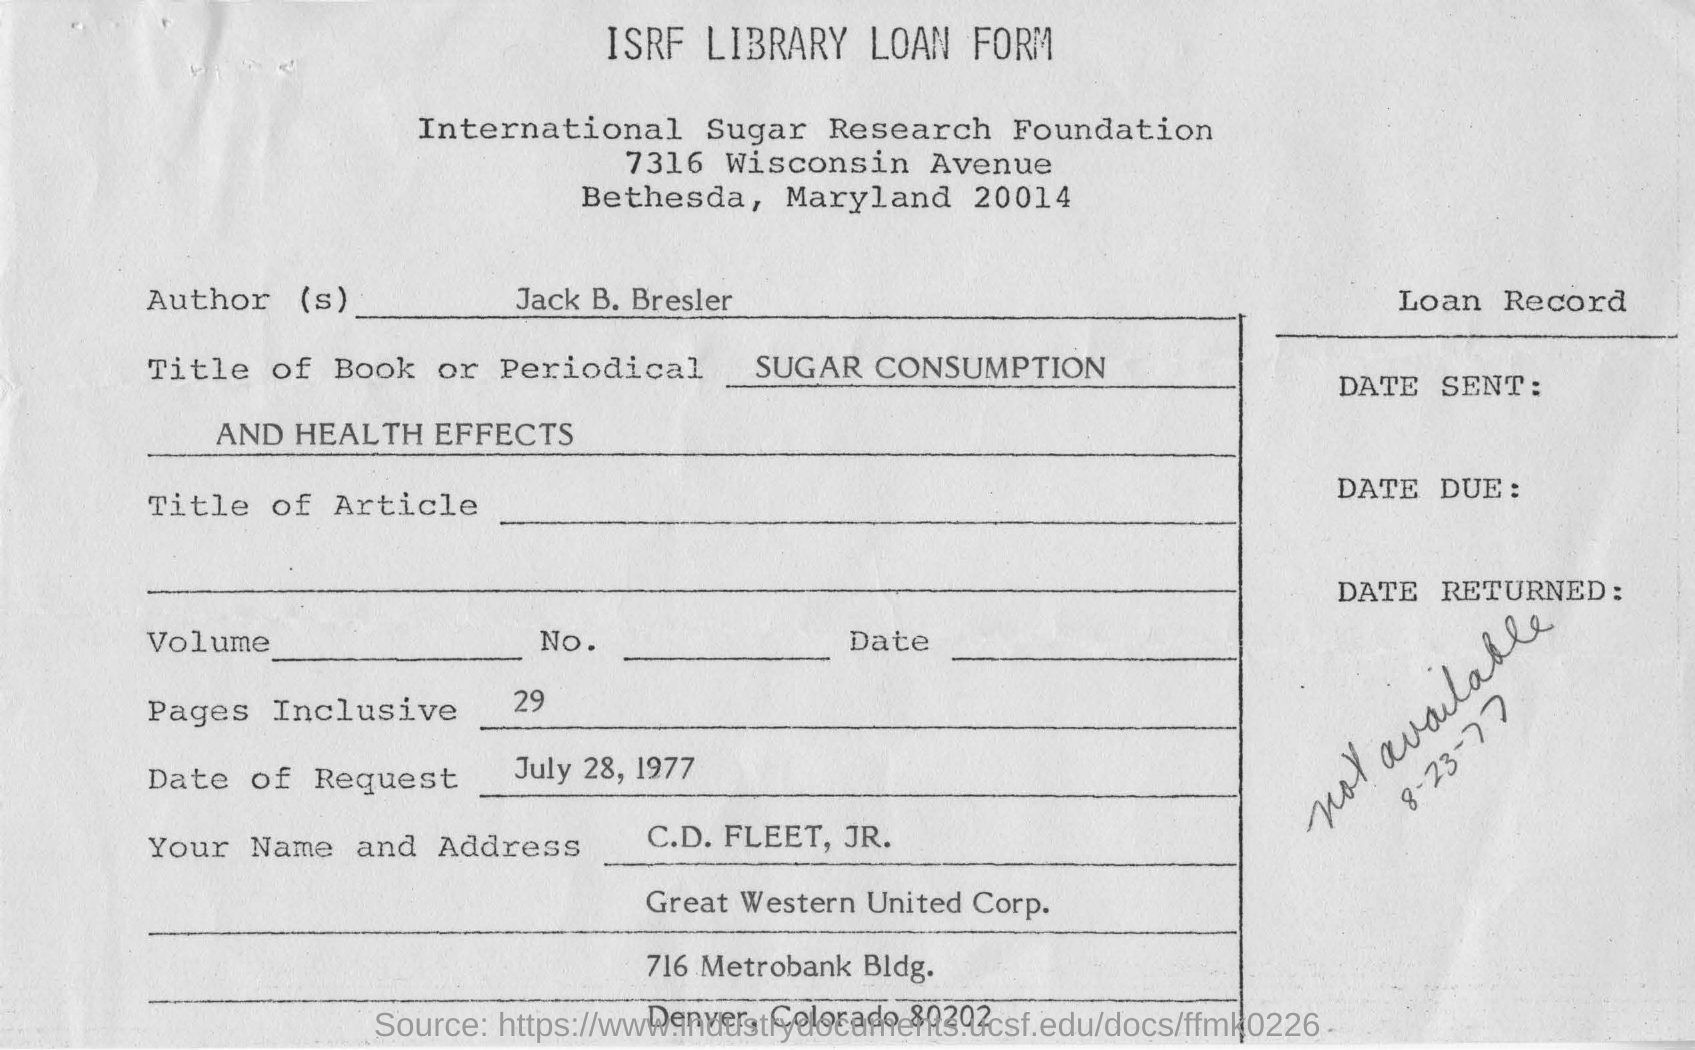Draw attention to some important aspects in this diagram. Jack B. Bresler is the author mentioned in this form. The full form of ISRF is International Sugar Research Foundation. The title of the book or periodical is 'SUGAR CONSUMPTION AND HEALTH EFFECTS'. The name given in the form for the applicant is C.D.FLEET, JR. There are 29 pages in total. 